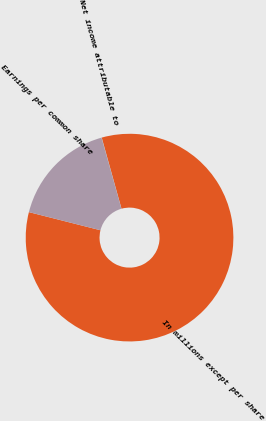Convert chart. <chart><loc_0><loc_0><loc_500><loc_500><pie_chart><fcel>In millions except per share<fcel>Net income attributable to<fcel>Earnings per common share<nl><fcel>83.27%<fcel>0.04%<fcel>16.69%<nl></chart> 